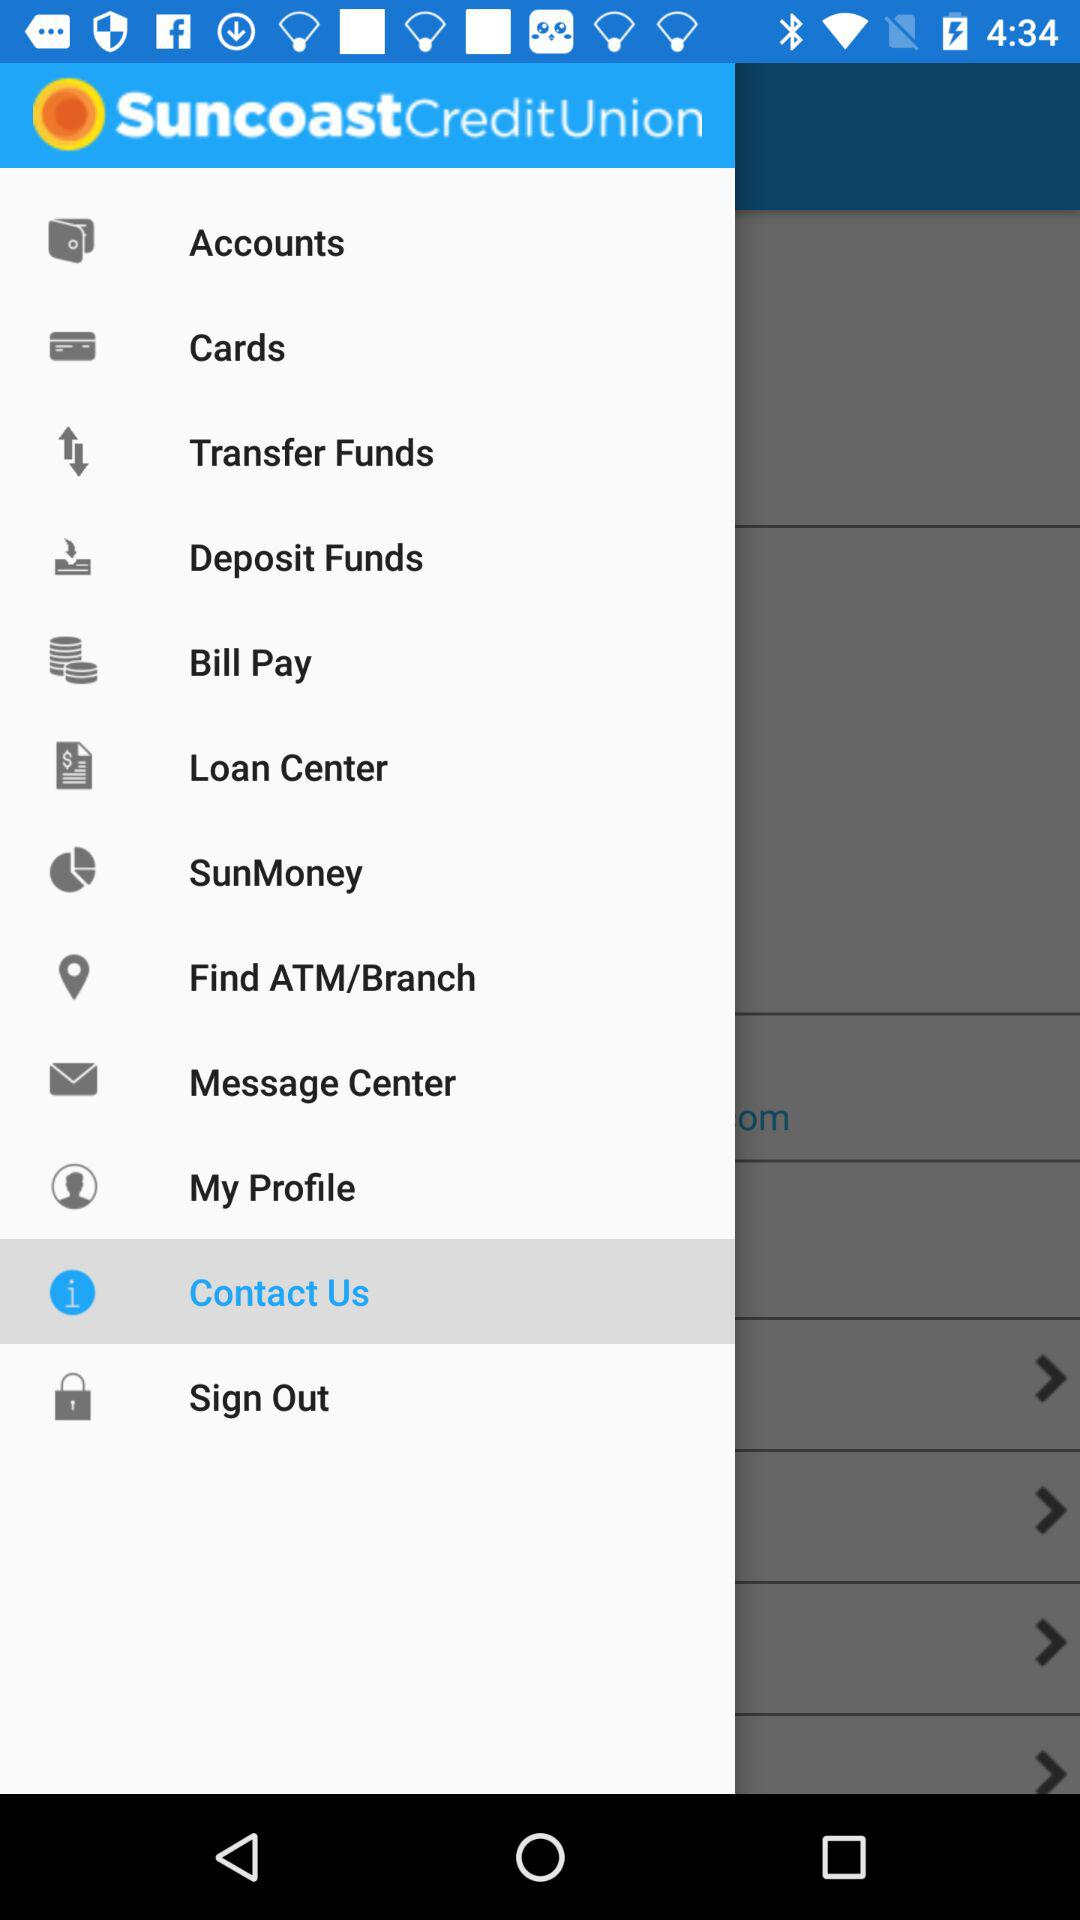Which is the selected category? The selected category is contact us. 